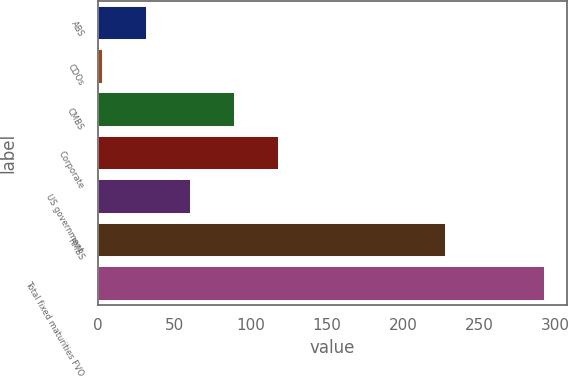Convert chart. <chart><loc_0><loc_0><loc_500><loc_500><bar_chart><fcel>ABS<fcel>CDOs<fcel>CMBS<fcel>Corporate<fcel>US government<fcel>RMBS<fcel>Total fixed maturities FVO<nl><fcel>32<fcel>3<fcel>90<fcel>119<fcel>61<fcel>228<fcel>293<nl></chart> 